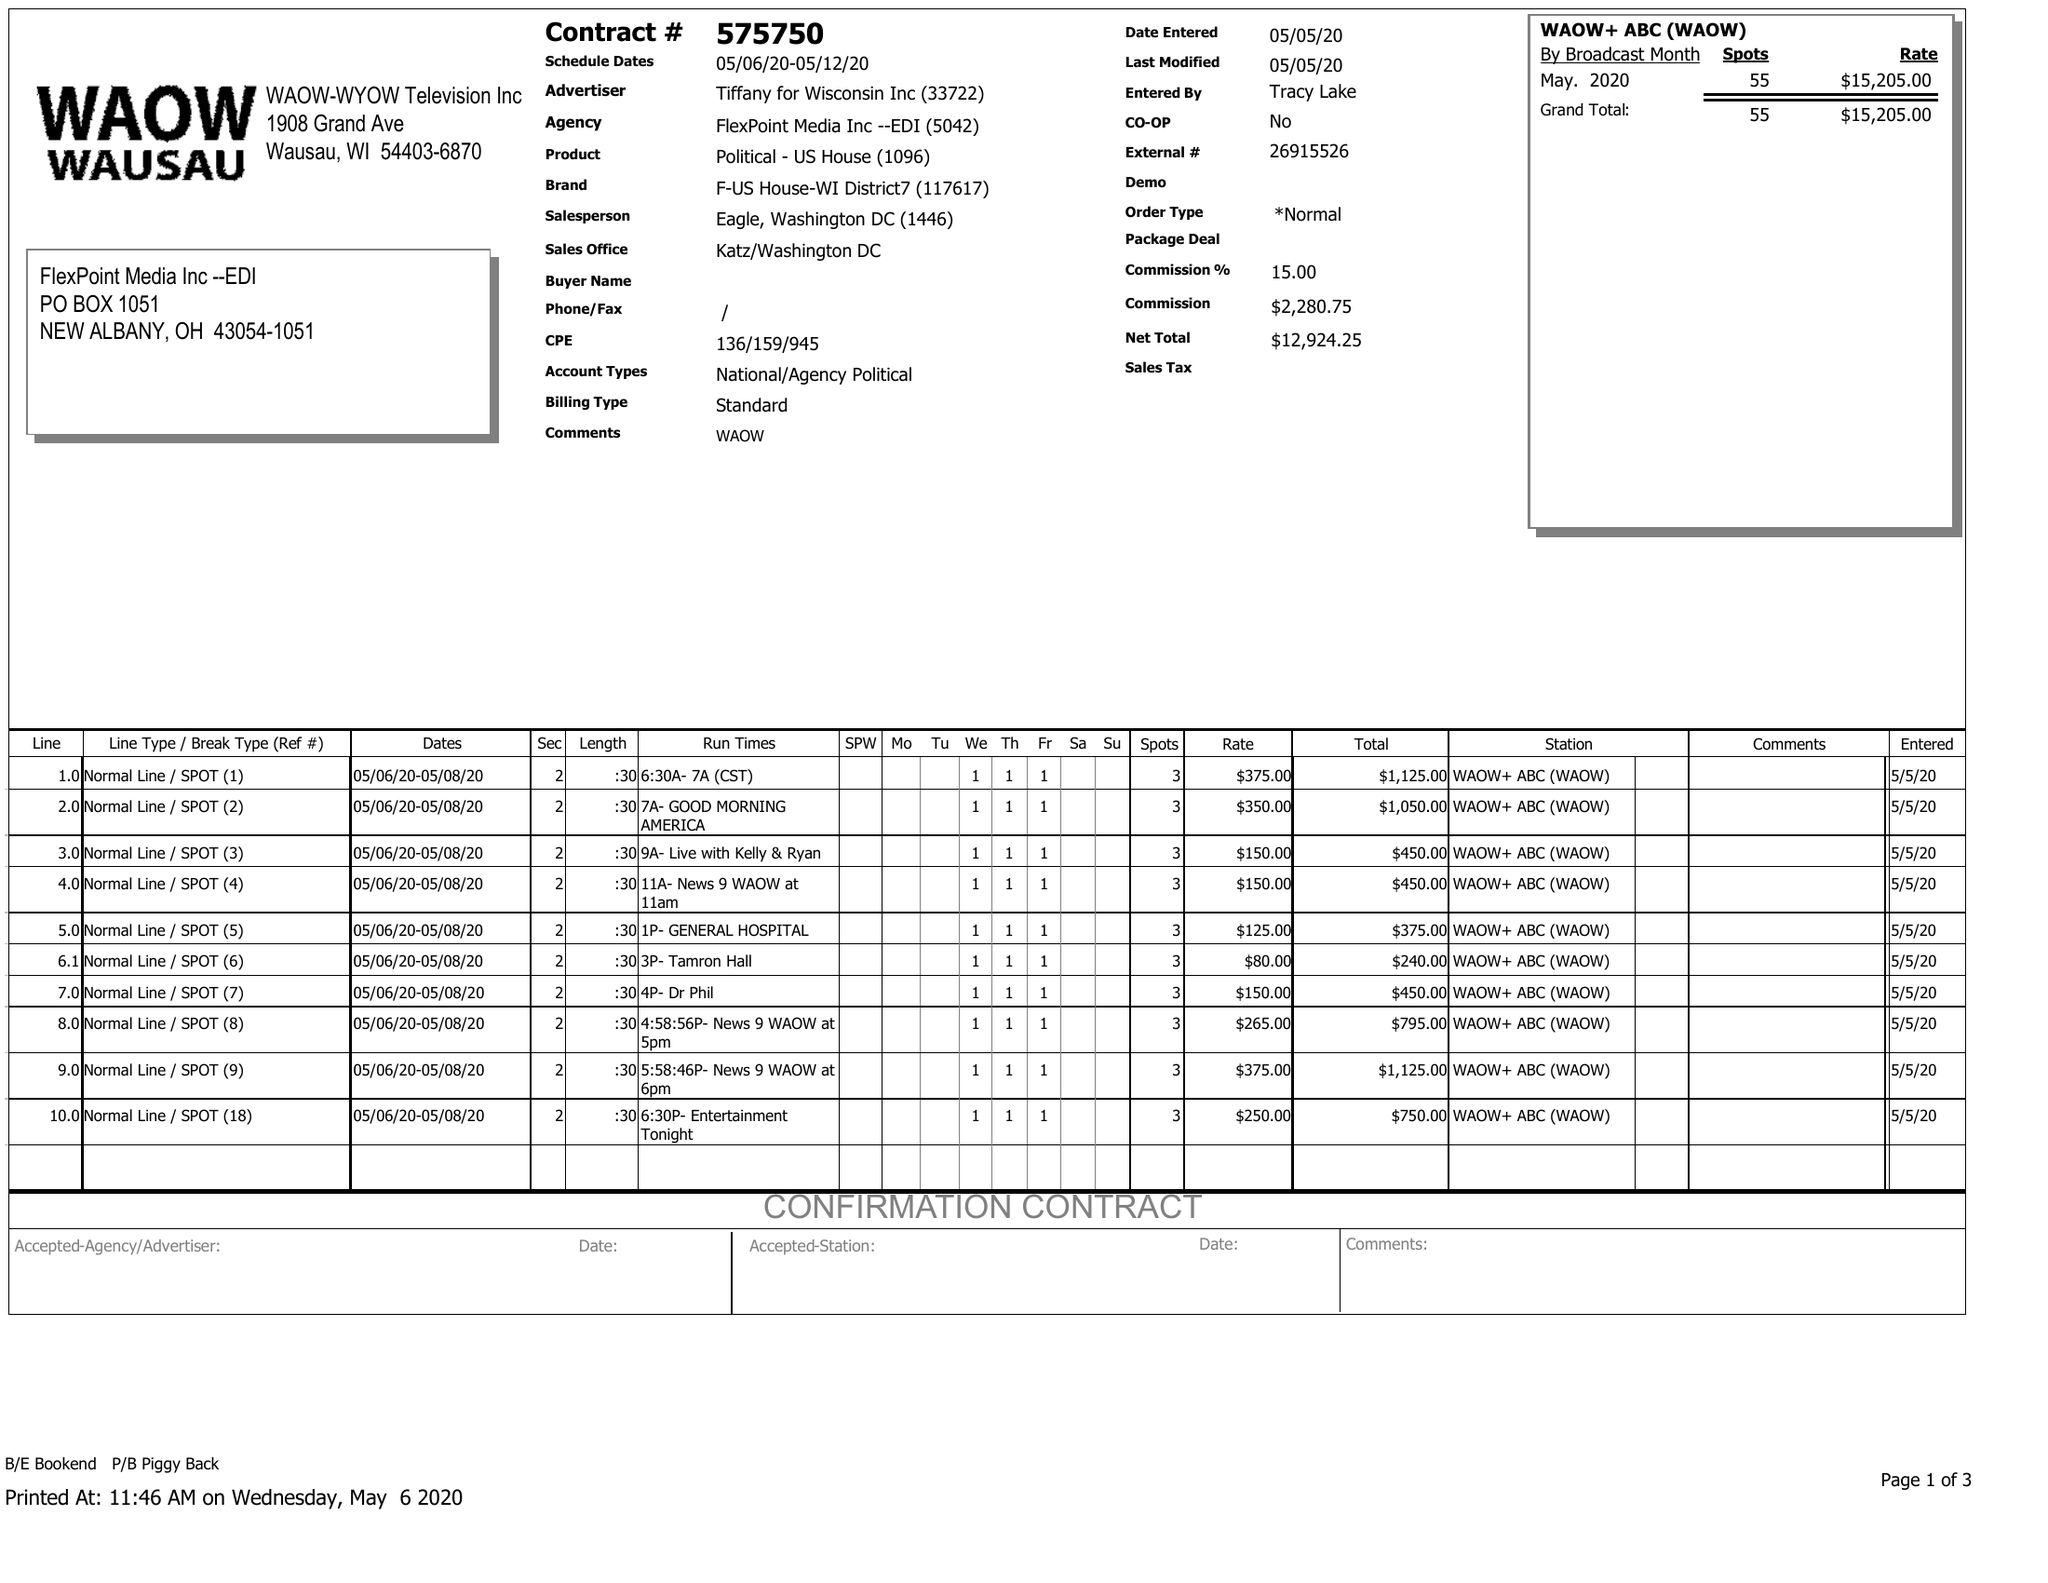What is the value for the gross_amount?
Answer the question using a single word or phrase. 15205.00 